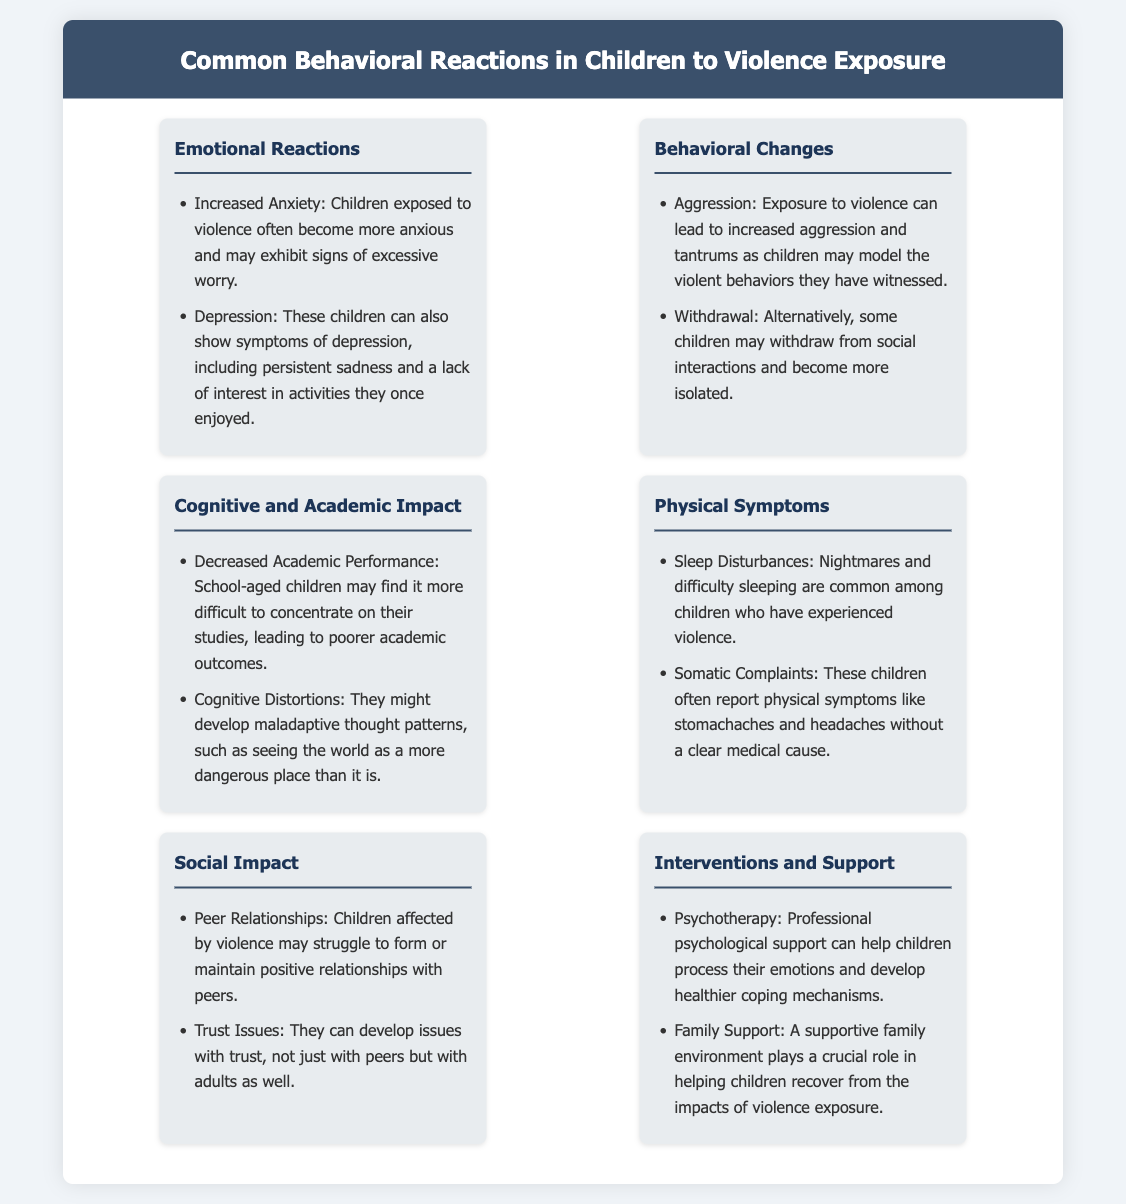what are two emotional reactions children may exhibit after exposure to violence? The document lists increased anxiety and depression as emotional reactions to violence exposure.
Answer: increased anxiety, depression what behavior change may occur due to violence exposure? The infographic states that exposure to violence can lead to increased aggression and withdrawal as behavior changes.
Answer: increased aggression, withdrawal what impact can violence exposure have on academic performance? It is mentioned that children may experience decreased academic performance following exposure to violence.
Answer: decreased academic performance what physical symptom is common among children exposed to violence? The document identifies sleep disturbances as a common physical symptom in these children.
Answer: sleep disturbances what are two recommended interventions for children affected by violence? The document suggests psychotherapy and family support as interventions.
Answer: psychotherapy, family support what cognitive distortion might children develop after exposure to violence? The infographic notes that children might see the world as a more dangerous place after experiencing violence.
Answer: a more dangerous place how do children affected by violence typically relate to peers? It states that children affected by violence may struggle to form or maintain positive relationships with peers.
Answer: struggle to form or maintain positive relationships what is a potential outcome of social impact due to violence exposure? Trust issues can develop as a social impact of exposure to violence according to the document.
Answer: trust issues 